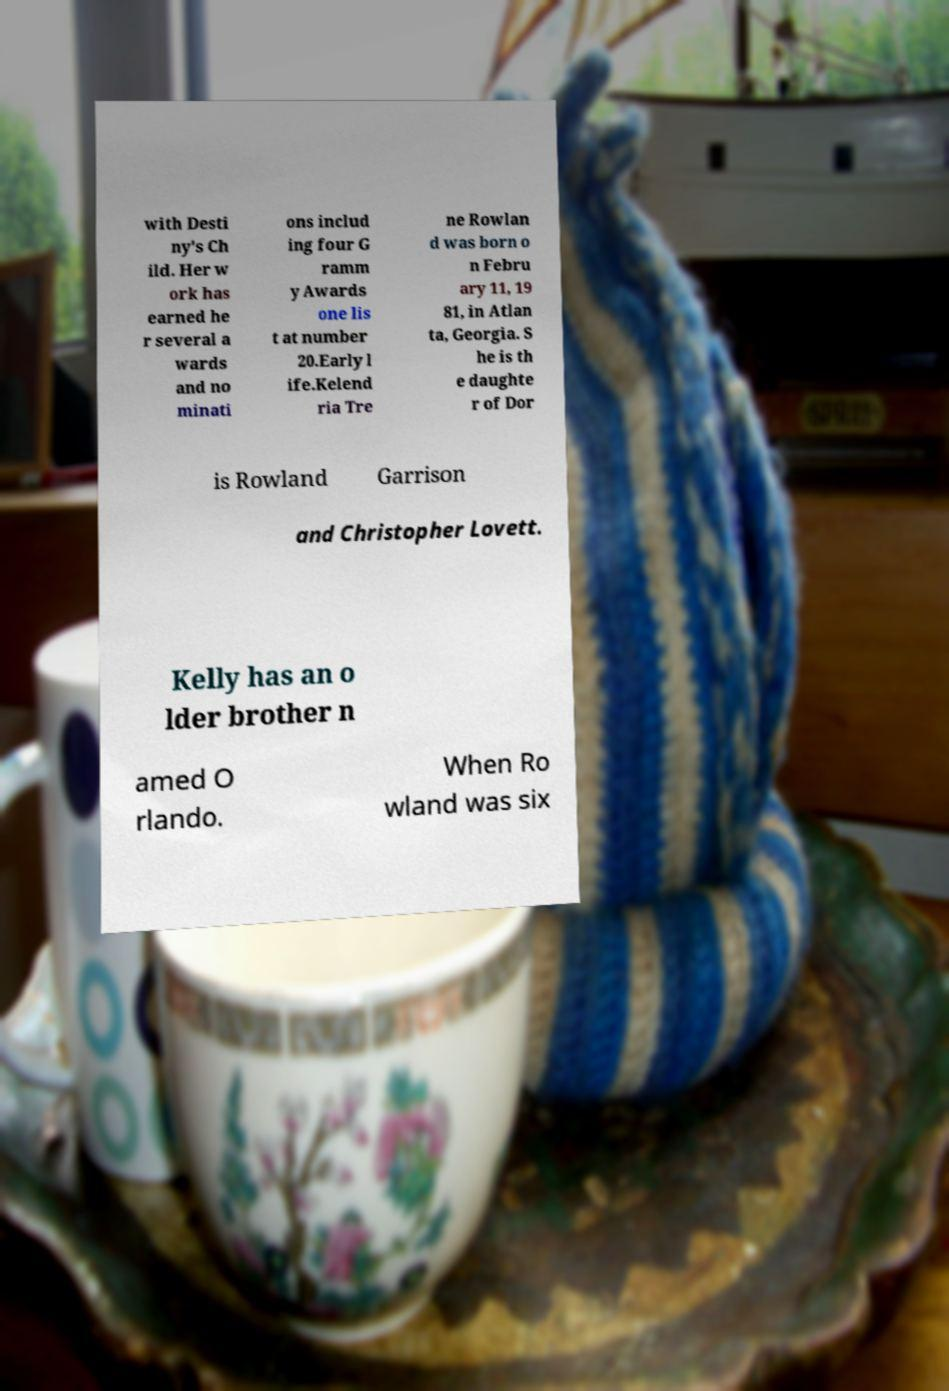Please read and relay the text visible in this image. What does it say? with Desti ny's Ch ild. Her w ork has earned he r several a wards and no minati ons includ ing four G ramm y Awards one lis t at number 20.Early l ife.Kelend ria Tre ne Rowlan d was born o n Febru ary 11, 19 81, in Atlan ta, Georgia. S he is th e daughte r of Dor is Rowland Garrison and Christopher Lovett. Kelly has an o lder brother n amed O rlando. When Ro wland was six 